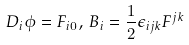<formula> <loc_0><loc_0><loc_500><loc_500>D _ { i } \phi = F _ { i 0 } , \, B _ { i } = \frac { 1 } { 2 } \epsilon _ { i j k } F ^ { j k }</formula> 